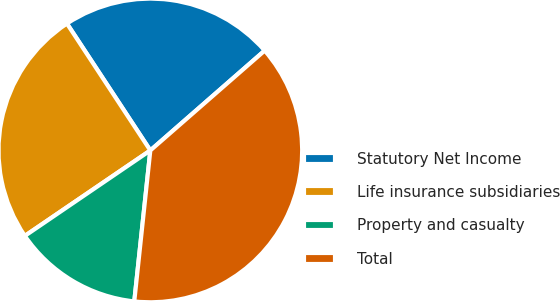<chart> <loc_0><loc_0><loc_500><loc_500><pie_chart><fcel>Statutory Net Income<fcel>Life insurance subsidiaries<fcel>Property and casualty<fcel>Total<nl><fcel>22.83%<fcel>25.26%<fcel>13.8%<fcel>38.11%<nl></chart> 